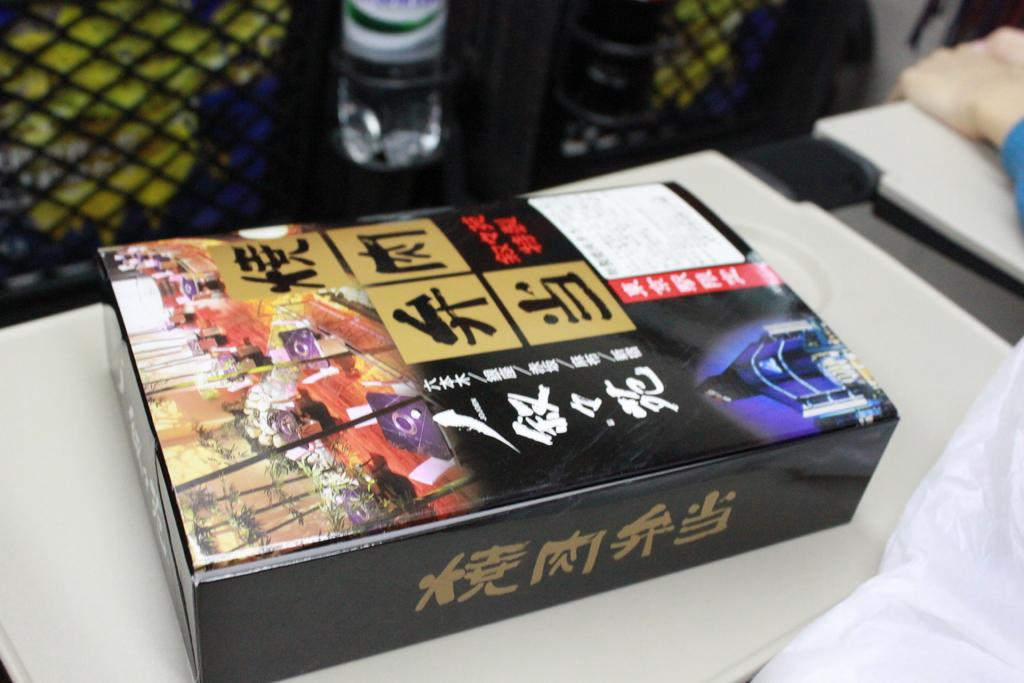What is the main object in the image? There is a box in the image. What is the color of the floor where the box is placed? The box is on a white floor. What colors can be seen on the box? The box has different colors written on it, including black, red, blue, and golden. What other object is visible beside the box? There is a bottle beside the box. Can you tell me how many police officers are touching the ball in the image? There is no ball or police officers present in the image. 